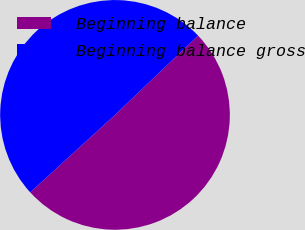<chart> <loc_0><loc_0><loc_500><loc_500><pie_chart><fcel>Beginning balance<fcel>Beginning balance gross<nl><fcel>50.35%<fcel>49.65%<nl></chart> 